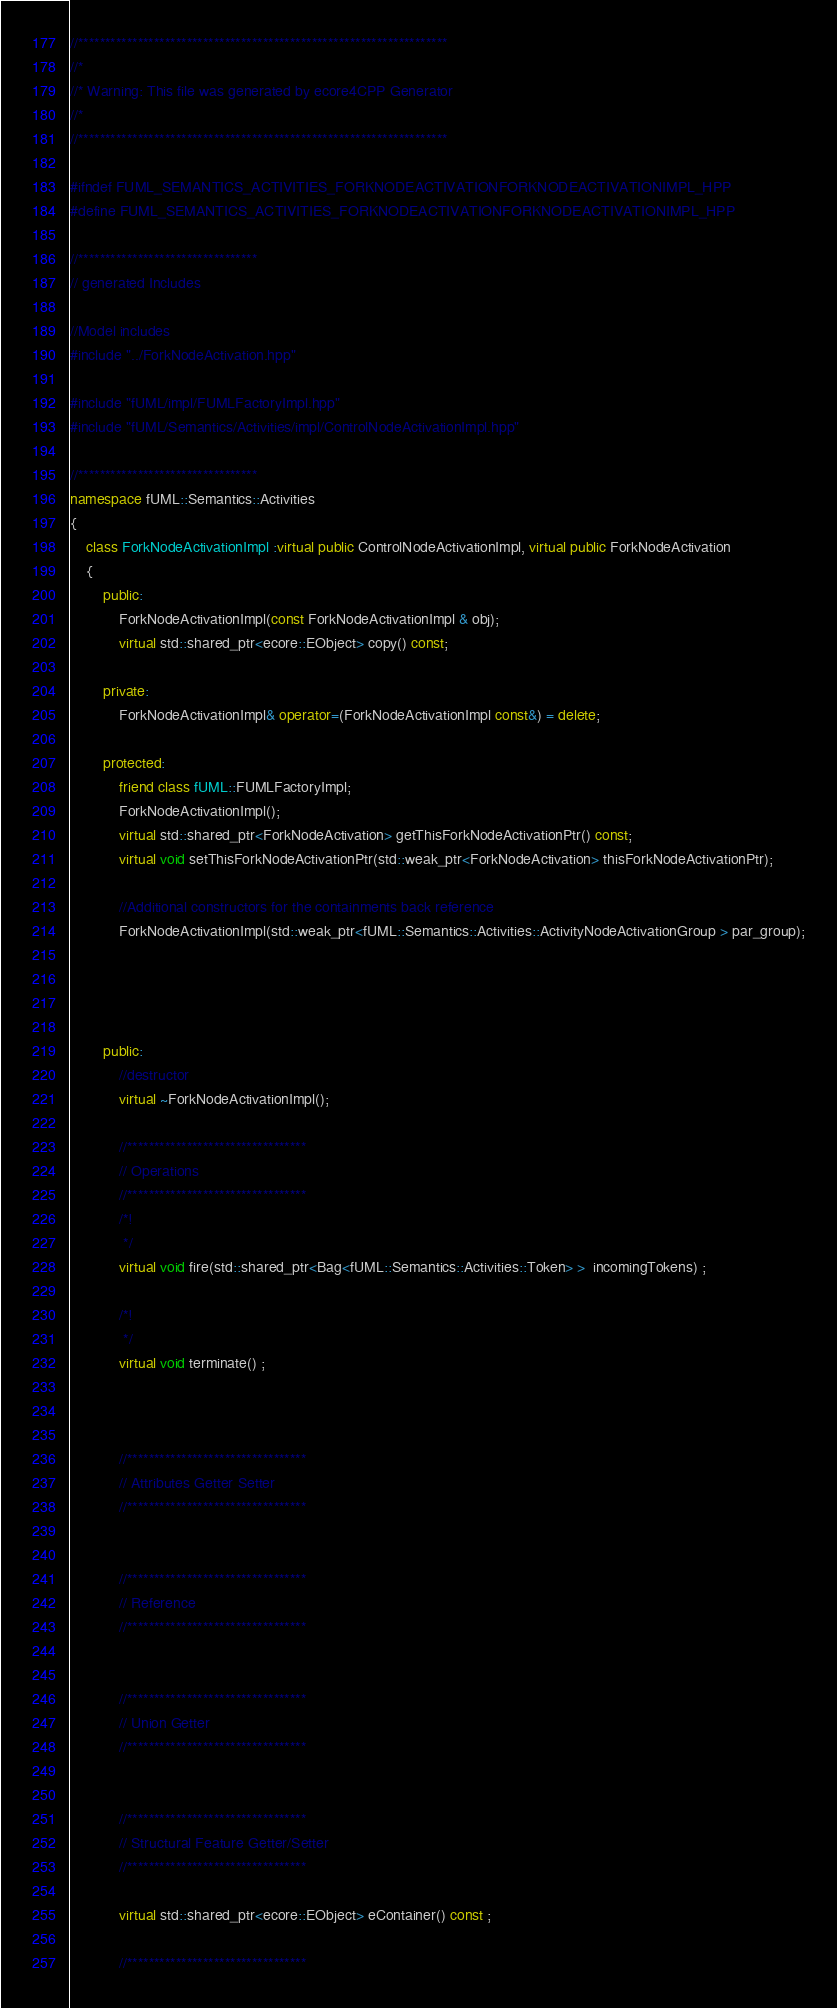<code> <loc_0><loc_0><loc_500><loc_500><_C++_>//********************************************************************
//*    
//* Warning: This file was generated by ecore4CPP Generator
//*
//********************************************************************

#ifndef FUML_SEMANTICS_ACTIVITIES_FORKNODEACTIVATIONFORKNODEACTIVATIONIMPL_HPP
#define FUML_SEMANTICS_ACTIVITIES_FORKNODEACTIVATIONFORKNODEACTIVATIONIMPL_HPP

//*********************************
// generated Includes

//Model includes
#include "../ForkNodeActivation.hpp"

#include "fUML/impl/FUMLFactoryImpl.hpp"
#include "fUML/Semantics/Activities/impl/ControlNodeActivationImpl.hpp"

//*********************************
namespace fUML::Semantics::Activities 
{
	class ForkNodeActivationImpl :virtual public ControlNodeActivationImpl, virtual public ForkNodeActivation 
	{
		public: 
			ForkNodeActivationImpl(const ForkNodeActivationImpl & obj);
			virtual std::shared_ptr<ecore::EObject> copy() const;

		private:    
			ForkNodeActivationImpl& operator=(ForkNodeActivationImpl const&) = delete;

		protected:
			friend class fUML::FUMLFactoryImpl;
			ForkNodeActivationImpl();
			virtual std::shared_ptr<ForkNodeActivation> getThisForkNodeActivationPtr() const;
			virtual void setThisForkNodeActivationPtr(std::weak_ptr<ForkNodeActivation> thisForkNodeActivationPtr);

			//Additional constructors for the containments back reference
			ForkNodeActivationImpl(std::weak_ptr<fUML::Semantics::Activities::ActivityNodeActivationGroup > par_group);




		public:
			//destructor
			virtual ~ForkNodeActivationImpl();
			
			//*********************************
			// Operations
			//*********************************
			/*!
			 */ 
			virtual void fire(std::shared_ptr<Bag<fUML::Semantics::Activities::Token> >  incomingTokens) ;
			
			/*!
			 */ 
			virtual void terminate() ;
			
			
			
			//*********************************
			// Attributes Getter Setter
			//*********************************
			
			
			//*********************************
			// Reference
			//*********************************
							
			
			//*********************************
			// Union Getter
			//*********************************
			 
			 
			//*********************************
			// Structural Feature Getter/Setter
			//*********************************

			virtual std::shared_ptr<ecore::EObject> eContainer() const ; 
			
			//*********************************</code> 